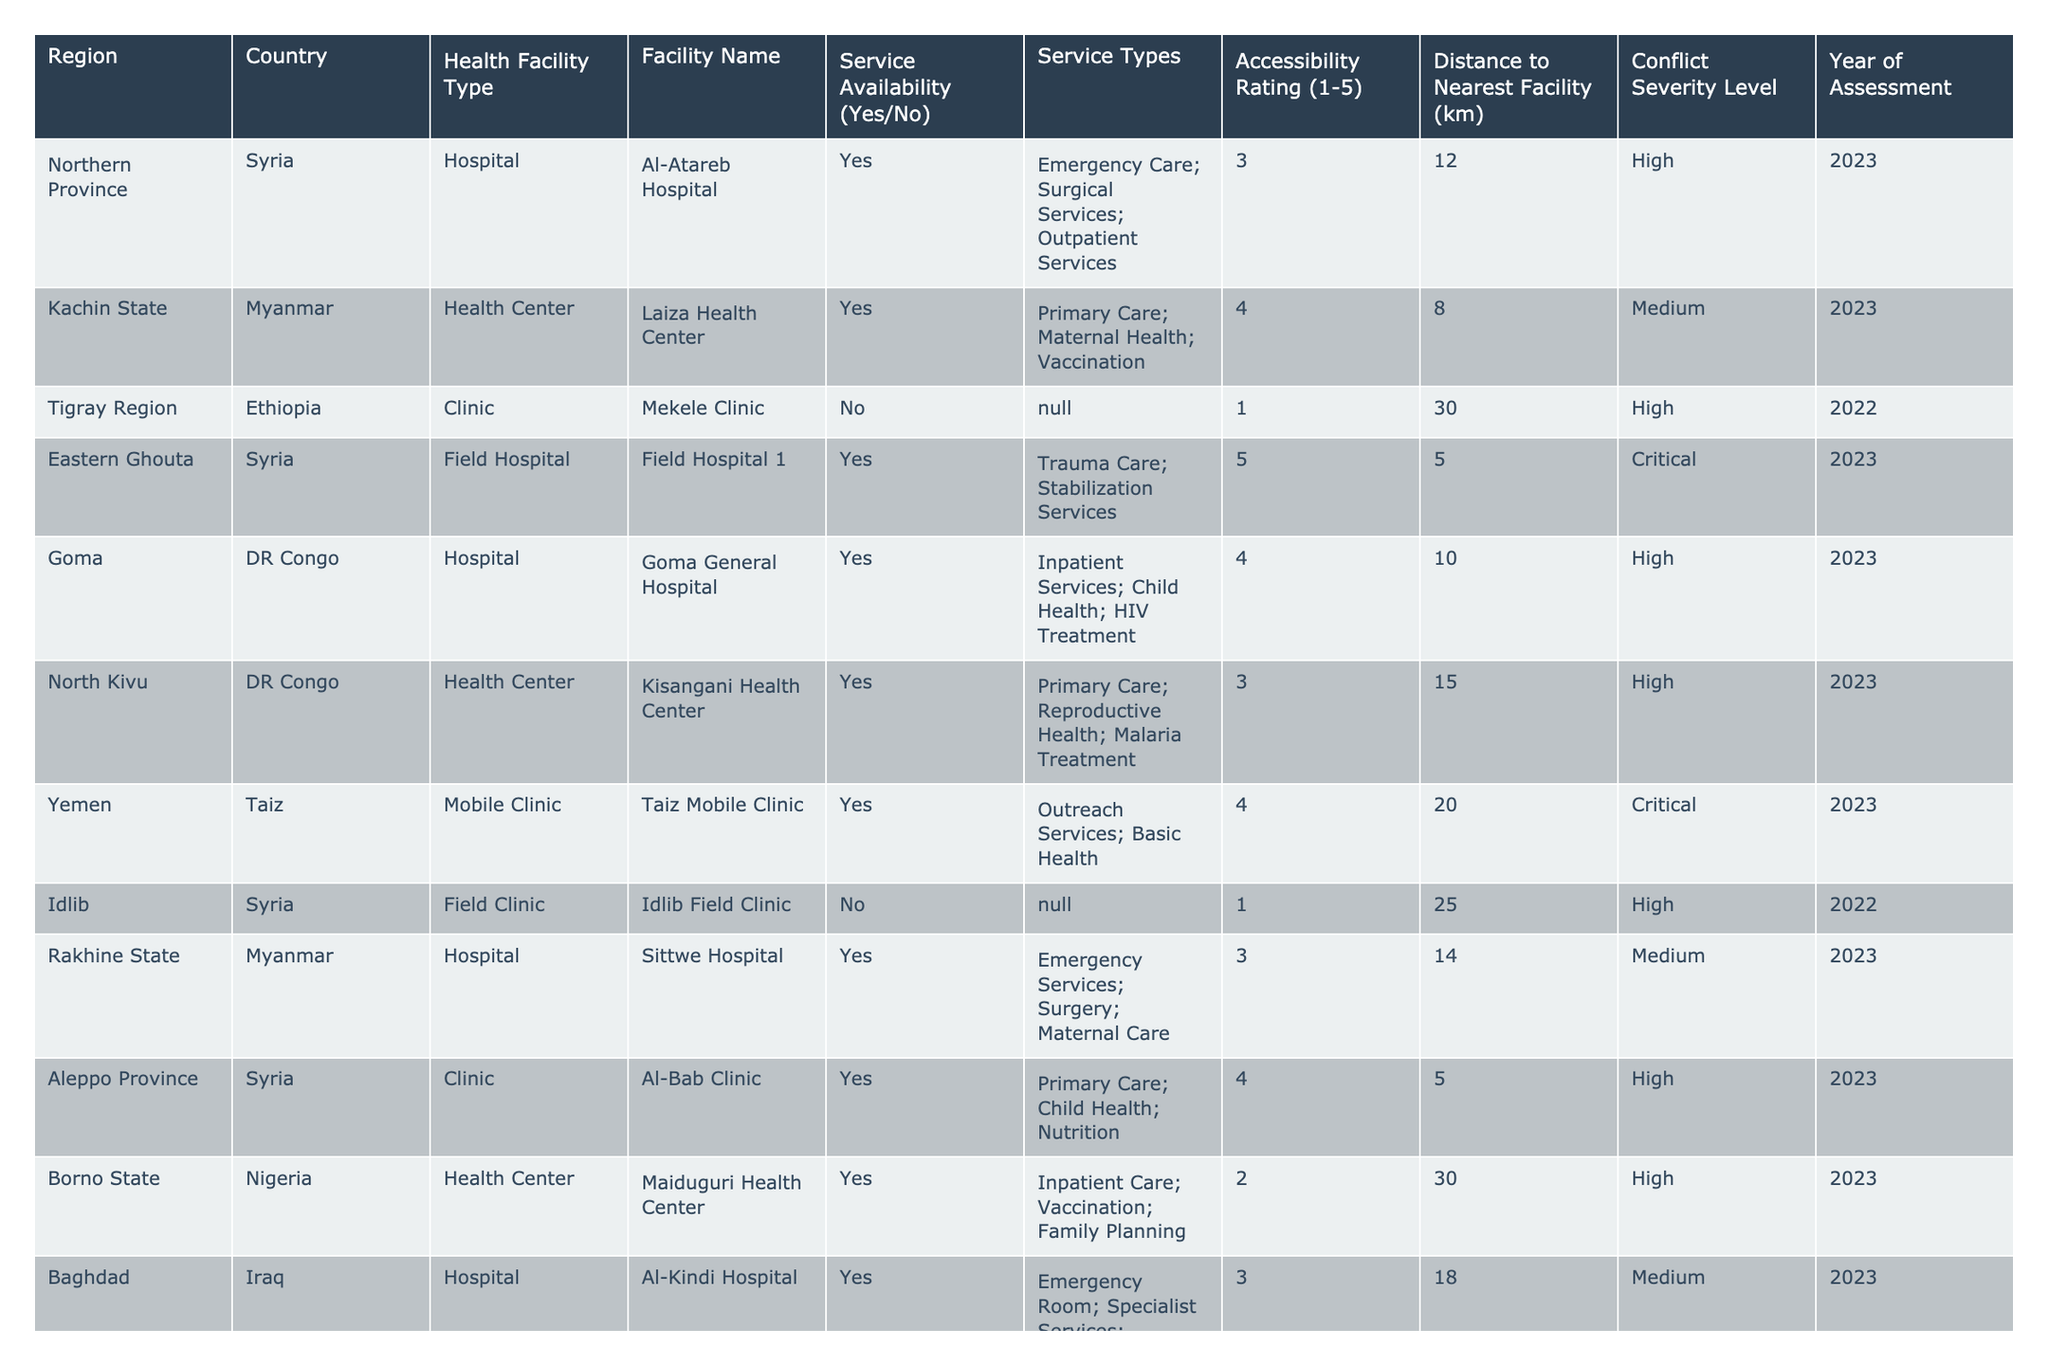What is the total number of health facilities assessed in 2023? The table includes health facilities from the year 2023: Al-Atareb Hospital, Laiza Health Center, Field Hospital 1, Goma General Hospital, Kisangani Health Center, Taiz Mobile Clinic, Sittwe Hospital, Al-Bab Clinic, Maiduguri Health Center, Al-Kindi Hospital, Health Post Delta, and Bor Teaching Hospital. That's a total of 12 facilities.
Answer: 12 Which facility in the Tigray Region of Ethiopia has no service availability? The Mekele Clinic in the Tigray Region is listed as having no service availability according to the table.
Answer: Mekele Clinic What is the distance to the nearest facility for the Idlib Field Clinic? The Idlib Field Clinic has a distance to the nearest facility marked as 25 km in the table.
Answer: 25 km How many health facilities have an accessibility rating of 5? Two facilities are rated 5 for accessibility: the Field Hospital 1 and the Lower Shabelle Mobile Clinic.
Answer: 2 Which country has the highest rated accessibility rating and what is that rating? The Lower Shabelle Mobile Clinic in Somalia has the highest accessibility rating of 5 among all facilities listed in the table.
Answer: Somalia, 5 What percentage of assessed facilities in 2023 have a service availability? Out of 12 facilities assessed in 2023, 10 have service availability (Yes). To find the percentage: (10/12) * 100 = 83.33%.
Answer: 83.33% Are there any clinics that provide trauma care services? Yes, the Field Hospital 1 in Eastern Ghouta provides trauma care services as stated in the service types column.
Answer: Yes What is the conflict severity level for the Goma General Hospital? The Goma General Hospital has a conflict severity level categorized as High.
Answer: High Which region has the farthest distance to the nearest health facility? The facility in Mindanao, Philippines has the farthest distance to the nearest health facility at 40 km.
Answer: Mindanao, 40 km List the service types provided by the Nilgala Health Unit. The Nilgala Health Unit provides Primary Healthcare, Mental Health, and TB Treatment as listed in the service types.
Answer: Primary Healthcare; Mental Health; TB Treatment Which type of health facility has the highest number of occurrences in the table? Hospitals are the most frequent type of health facility, appearing 7 times in total according to the table data.
Answer: Hospitals 